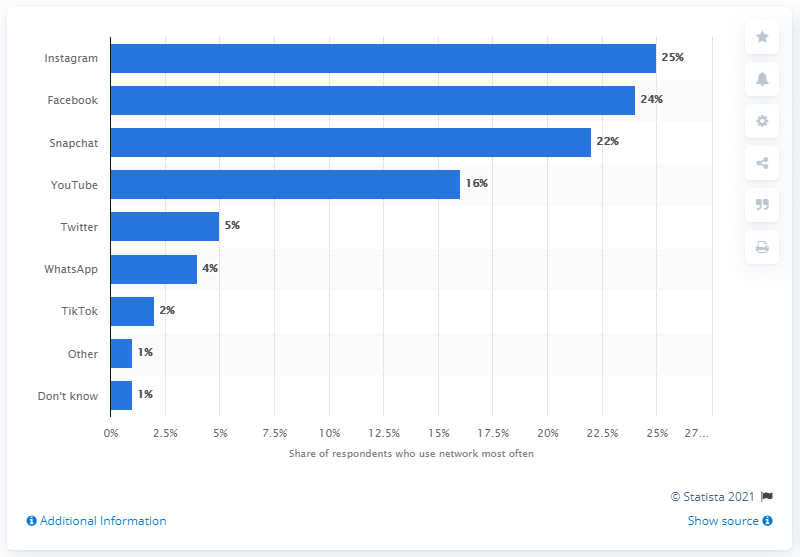List a handful of essential elements in this visual. According to a survey conducted in September 2019, Facebook and Instagram account for 49% of the total amount of social networks used by teenagers in the United States. According to data collected in September 2019, Instagram was the most popular social network among teenagers in the United States. 